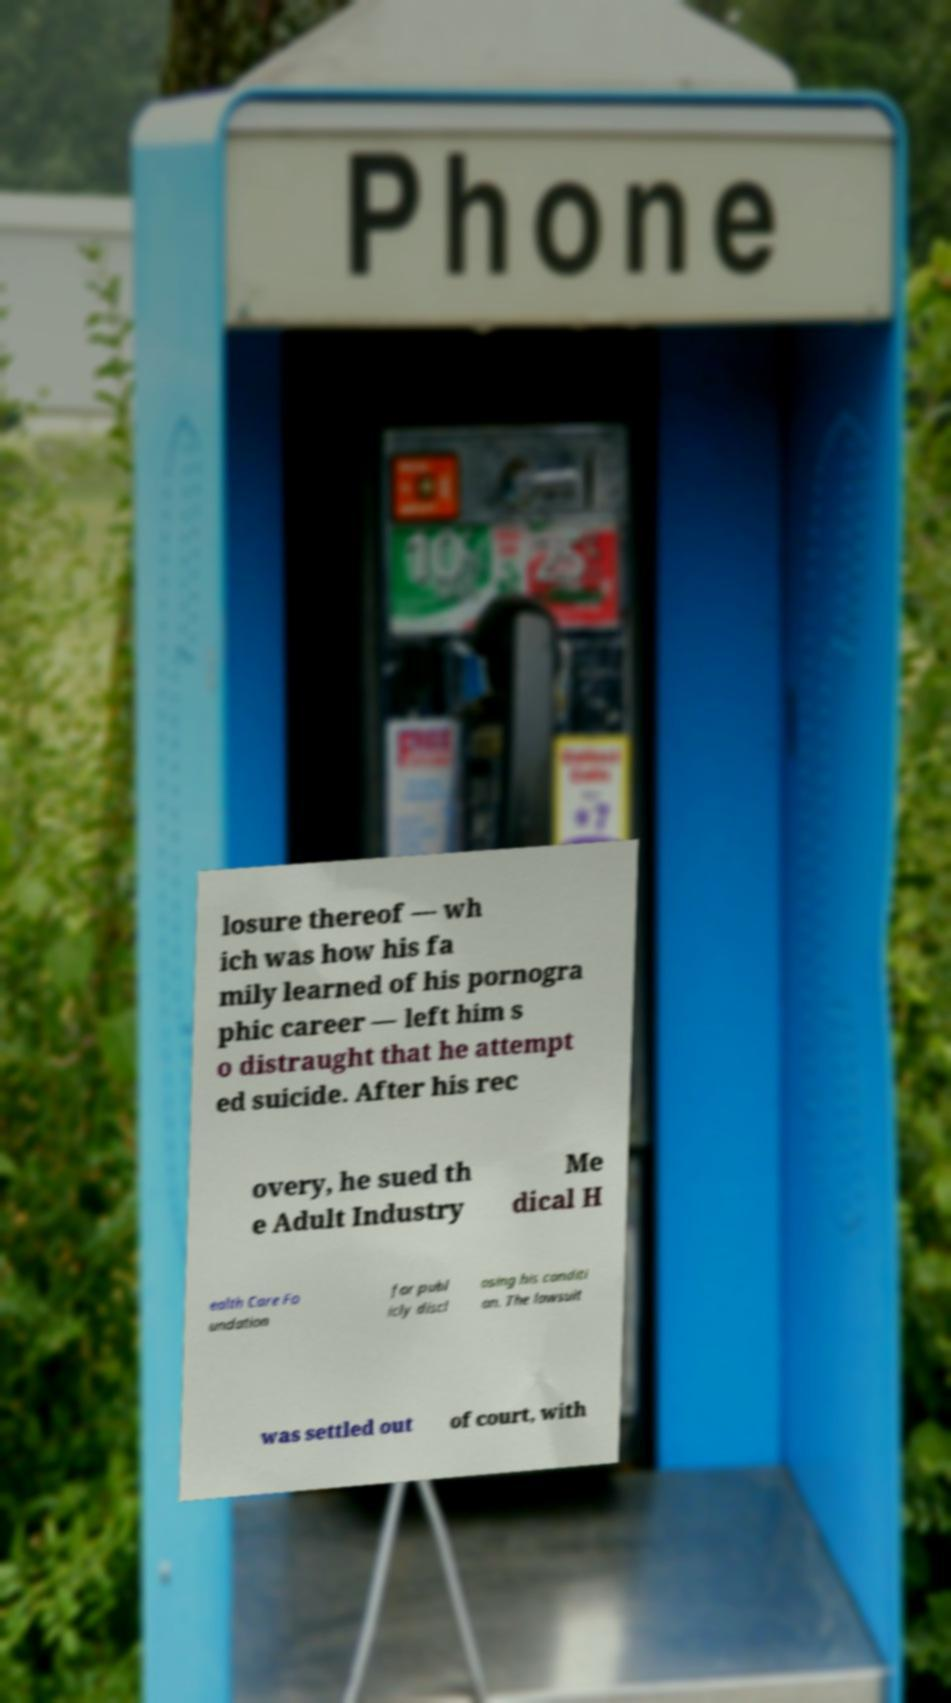What messages or text are displayed in this image? I need them in a readable, typed format. losure thereof — wh ich was how his fa mily learned of his pornogra phic career — left him s o distraught that he attempt ed suicide. After his rec overy, he sued th e Adult Industry Me dical H ealth Care Fo undation for publ icly discl osing his conditi on. The lawsuit was settled out of court, with 